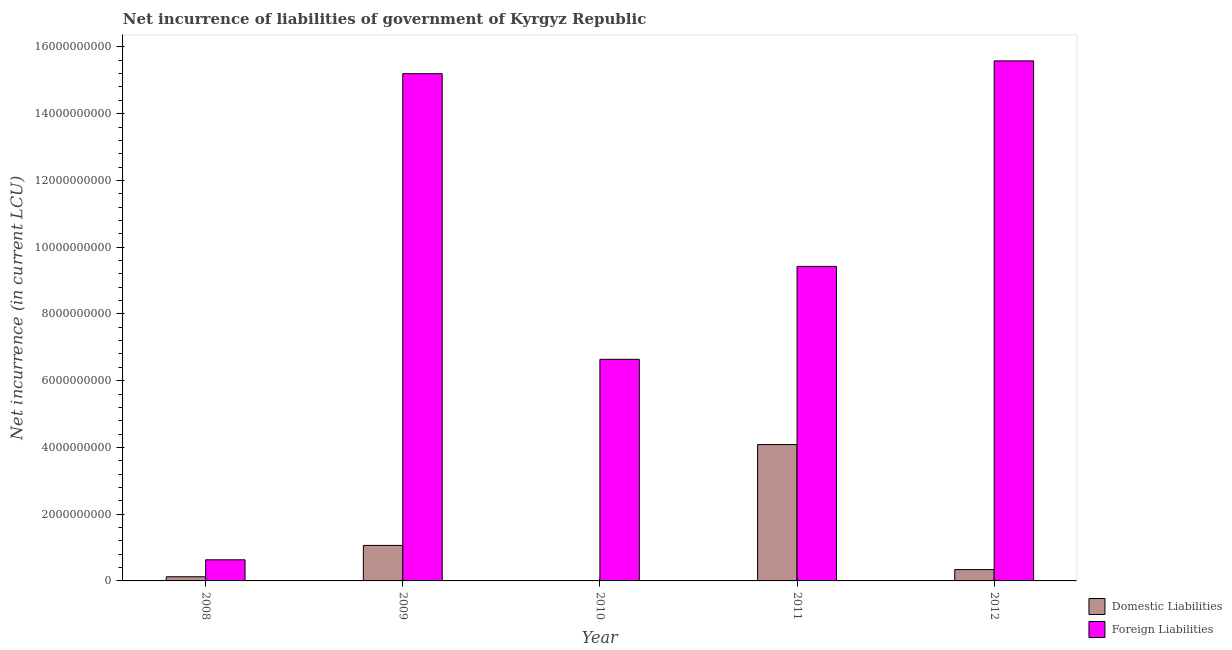Are the number of bars per tick equal to the number of legend labels?
Keep it short and to the point. No. How many bars are there on the 1st tick from the left?
Give a very brief answer. 2. What is the label of the 3rd group of bars from the left?
Your answer should be compact. 2010. What is the net incurrence of foreign liabilities in 2008?
Your answer should be very brief. 6.33e+08. Across all years, what is the maximum net incurrence of domestic liabilities?
Provide a short and direct response. 4.09e+09. Across all years, what is the minimum net incurrence of domestic liabilities?
Ensure brevity in your answer.  0. What is the total net incurrence of domestic liabilities in the graph?
Give a very brief answer. 5.61e+09. What is the difference between the net incurrence of domestic liabilities in 2011 and that in 2012?
Your answer should be very brief. 3.75e+09. What is the difference between the net incurrence of foreign liabilities in 2012 and the net incurrence of domestic liabilities in 2010?
Provide a succinct answer. 8.94e+09. What is the average net incurrence of domestic liabilities per year?
Make the answer very short. 1.12e+09. In the year 2009, what is the difference between the net incurrence of domestic liabilities and net incurrence of foreign liabilities?
Give a very brief answer. 0. In how many years, is the net incurrence of foreign liabilities greater than 6000000000 LCU?
Your answer should be compact. 4. What is the ratio of the net incurrence of domestic liabilities in 2009 to that in 2011?
Give a very brief answer. 0.26. Is the difference between the net incurrence of domestic liabilities in 2011 and 2012 greater than the difference between the net incurrence of foreign liabilities in 2011 and 2012?
Your answer should be compact. No. What is the difference between the highest and the second highest net incurrence of foreign liabilities?
Offer a very short reply. 3.84e+08. What is the difference between the highest and the lowest net incurrence of foreign liabilities?
Ensure brevity in your answer.  1.49e+1. In how many years, is the net incurrence of domestic liabilities greater than the average net incurrence of domestic liabilities taken over all years?
Ensure brevity in your answer.  1. Is the sum of the net incurrence of foreign liabilities in 2008 and 2012 greater than the maximum net incurrence of domestic liabilities across all years?
Keep it short and to the point. Yes. Are all the bars in the graph horizontal?
Ensure brevity in your answer.  No. How many years are there in the graph?
Provide a short and direct response. 5. What is the title of the graph?
Make the answer very short. Net incurrence of liabilities of government of Kyrgyz Republic. Does "Private creditors" appear as one of the legend labels in the graph?
Your response must be concise. No. What is the label or title of the X-axis?
Your response must be concise. Year. What is the label or title of the Y-axis?
Provide a short and direct response. Net incurrence (in current LCU). What is the Net incurrence (in current LCU) of Domestic Liabilities in 2008?
Offer a very short reply. 1.25e+08. What is the Net incurrence (in current LCU) in Foreign Liabilities in 2008?
Offer a very short reply. 6.33e+08. What is the Net incurrence (in current LCU) of Domestic Liabilities in 2009?
Offer a terse response. 1.06e+09. What is the Net incurrence (in current LCU) in Foreign Liabilities in 2009?
Make the answer very short. 1.52e+1. What is the Net incurrence (in current LCU) in Foreign Liabilities in 2010?
Your answer should be compact. 6.64e+09. What is the Net incurrence (in current LCU) in Domestic Liabilities in 2011?
Ensure brevity in your answer.  4.09e+09. What is the Net incurrence (in current LCU) of Foreign Liabilities in 2011?
Ensure brevity in your answer.  9.42e+09. What is the Net incurrence (in current LCU) in Domestic Liabilities in 2012?
Offer a very short reply. 3.40e+08. What is the Net incurrence (in current LCU) in Foreign Liabilities in 2012?
Offer a terse response. 1.56e+1. Across all years, what is the maximum Net incurrence (in current LCU) of Domestic Liabilities?
Provide a succinct answer. 4.09e+09. Across all years, what is the maximum Net incurrence (in current LCU) of Foreign Liabilities?
Give a very brief answer. 1.56e+1. Across all years, what is the minimum Net incurrence (in current LCU) of Domestic Liabilities?
Make the answer very short. 0. Across all years, what is the minimum Net incurrence (in current LCU) in Foreign Liabilities?
Offer a very short reply. 6.33e+08. What is the total Net incurrence (in current LCU) in Domestic Liabilities in the graph?
Keep it short and to the point. 5.61e+09. What is the total Net incurrence (in current LCU) of Foreign Liabilities in the graph?
Provide a short and direct response. 4.75e+1. What is the difference between the Net incurrence (in current LCU) of Domestic Liabilities in 2008 and that in 2009?
Keep it short and to the point. -9.39e+08. What is the difference between the Net incurrence (in current LCU) of Foreign Liabilities in 2008 and that in 2009?
Keep it short and to the point. -1.46e+1. What is the difference between the Net incurrence (in current LCU) of Foreign Liabilities in 2008 and that in 2010?
Provide a succinct answer. -6.01e+09. What is the difference between the Net incurrence (in current LCU) in Domestic Liabilities in 2008 and that in 2011?
Give a very brief answer. -3.96e+09. What is the difference between the Net incurrence (in current LCU) of Foreign Liabilities in 2008 and that in 2011?
Give a very brief answer. -8.79e+09. What is the difference between the Net incurrence (in current LCU) in Domestic Liabilities in 2008 and that in 2012?
Your answer should be compact. -2.15e+08. What is the difference between the Net incurrence (in current LCU) of Foreign Liabilities in 2008 and that in 2012?
Keep it short and to the point. -1.49e+1. What is the difference between the Net incurrence (in current LCU) in Foreign Liabilities in 2009 and that in 2010?
Offer a terse response. 8.56e+09. What is the difference between the Net incurrence (in current LCU) of Domestic Liabilities in 2009 and that in 2011?
Your response must be concise. -3.02e+09. What is the difference between the Net incurrence (in current LCU) in Foreign Liabilities in 2009 and that in 2011?
Give a very brief answer. 5.77e+09. What is the difference between the Net incurrence (in current LCU) of Domestic Liabilities in 2009 and that in 2012?
Your answer should be very brief. 7.24e+08. What is the difference between the Net incurrence (in current LCU) in Foreign Liabilities in 2009 and that in 2012?
Make the answer very short. -3.84e+08. What is the difference between the Net incurrence (in current LCU) of Foreign Liabilities in 2010 and that in 2011?
Offer a very short reply. -2.78e+09. What is the difference between the Net incurrence (in current LCU) in Foreign Liabilities in 2010 and that in 2012?
Provide a short and direct response. -8.94e+09. What is the difference between the Net incurrence (in current LCU) of Domestic Liabilities in 2011 and that in 2012?
Offer a terse response. 3.75e+09. What is the difference between the Net incurrence (in current LCU) in Foreign Liabilities in 2011 and that in 2012?
Provide a succinct answer. -6.16e+09. What is the difference between the Net incurrence (in current LCU) in Domestic Liabilities in 2008 and the Net incurrence (in current LCU) in Foreign Liabilities in 2009?
Your answer should be compact. -1.51e+1. What is the difference between the Net incurrence (in current LCU) in Domestic Liabilities in 2008 and the Net incurrence (in current LCU) in Foreign Liabilities in 2010?
Ensure brevity in your answer.  -6.51e+09. What is the difference between the Net incurrence (in current LCU) in Domestic Liabilities in 2008 and the Net incurrence (in current LCU) in Foreign Liabilities in 2011?
Your response must be concise. -9.30e+09. What is the difference between the Net incurrence (in current LCU) in Domestic Liabilities in 2008 and the Net incurrence (in current LCU) in Foreign Liabilities in 2012?
Offer a terse response. -1.55e+1. What is the difference between the Net incurrence (in current LCU) of Domestic Liabilities in 2009 and the Net incurrence (in current LCU) of Foreign Liabilities in 2010?
Your answer should be compact. -5.58e+09. What is the difference between the Net incurrence (in current LCU) in Domestic Liabilities in 2009 and the Net incurrence (in current LCU) in Foreign Liabilities in 2011?
Ensure brevity in your answer.  -8.36e+09. What is the difference between the Net incurrence (in current LCU) of Domestic Liabilities in 2009 and the Net incurrence (in current LCU) of Foreign Liabilities in 2012?
Keep it short and to the point. -1.45e+1. What is the difference between the Net incurrence (in current LCU) in Domestic Liabilities in 2011 and the Net incurrence (in current LCU) in Foreign Liabilities in 2012?
Make the answer very short. -1.15e+1. What is the average Net incurrence (in current LCU) of Domestic Liabilities per year?
Offer a very short reply. 1.12e+09. What is the average Net incurrence (in current LCU) in Foreign Liabilities per year?
Keep it short and to the point. 9.50e+09. In the year 2008, what is the difference between the Net incurrence (in current LCU) of Domestic Liabilities and Net incurrence (in current LCU) of Foreign Liabilities?
Your answer should be compact. -5.08e+08. In the year 2009, what is the difference between the Net incurrence (in current LCU) in Domestic Liabilities and Net incurrence (in current LCU) in Foreign Liabilities?
Your answer should be very brief. -1.41e+1. In the year 2011, what is the difference between the Net incurrence (in current LCU) of Domestic Liabilities and Net incurrence (in current LCU) of Foreign Liabilities?
Offer a terse response. -5.34e+09. In the year 2012, what is the difference between the Net incurrence (in current LCU) in Domestic Liabilities and Net incurrence (in current LCU) in Foreign Liabilities?
Offer a terse response. -1.52e+1. What is the ratio of the Net incurrence (in current LCU) in Domestic Liabilities in 2008 to that in 2009?
Offer a very short reply. 0.12. What is the ratio of the Net incurrence (in current LCU) of Foreign Liabilities in 2008 to that in 2009?
Provide a succinct answer. 0.04. What is the ratio of the Net incurrence (in current LCU) in Foreign Liabilities in 2008 to that in 2010?
Offer a very short reply. 0.1. What is the ratio of the Net incurrence (in current LCU) of Domestic Liabilities in 2008 to that in 2011?
Provide a short and direct response. 0.03. What is the ratio of the Net incurrence (in current LCU) of Foreign Liabilities in 2008 to that in 2011?
Offer a terse response. 0.07. What is the ratio of the Net incurrence (in current LCU) of Domestic Liabilities in 2008 to that in 2012?
Offer a terse response. 0.37. What is the ratio of the Net incurrence (in current LCU) in Foreign Liabilities in 2008 to that in 2012?
Make the answer very short. 0.04. What is the ratio of the Net incurrence (in current LCU) in Foreign Liabilities in 2009 to that in 2010?
Provide a succinct answer. 2.29. What is the ratio of the Net incurrence (in current LCU) in Domestic Liabilities in 2009 to that in 2011?
Your answer should be very brief. 0.26. What is the ratio of the Net incurrence (in current LCU) in Foreign Liabilities in 2009 to that in 2011?
Your answer should be compact. 1.61. What is the ratio of the Net incurrence (in current LCU) of Domestic Liabilities in 2009 to that in 2012?
Make the answer very short. 3.13. What is the ratio of the Net incurrence (in current LCU) in Foreign Liabilities in 2009 to that in 2012?
Your answer should be compact. 0.98. What is the ratio of the Net incurrence (in current LCU) of Foreign Liabilities in 2010 to that in 2011?
Make the answer very short. 0.7. What is the ratio of the Net incurrence (in current LCU) of Foreign Liabilities in 2010 to that in 2012?
Ensure brevity in your answer.  0.43. What is the ratio of the Net incurrence (in current LCU) in Domestic Liabilities in 2011 to that in 2012?
Provide a succinct answer. 12.02. What is the ratio of the Net incurrence (in current LCU) of Foreign Liabilities in 2011 to that in 2012?
Provide a succinct answer. 0.6. What is the difference between the highest and the second highest Net incurrence (in current LCU) of Domestic Liabilities?
Provide a short and direct response. 3.02e+09. What is the difference between the highest and the second highest Net incurrence (in current LCU) in Foreign Liabilities?
Provide a short and direct response. 3.84e+08. What is the difference between the highest and the lowest Net incurrence (in current LCU) of Domestic Liabilities?
Your answer should be very brief. 4.09e+09. What is the difference between the highest and the lowest Net incurrence (in current LCU) of Foreign Liabilities?
Offer a terse response. 1.49e+1. 